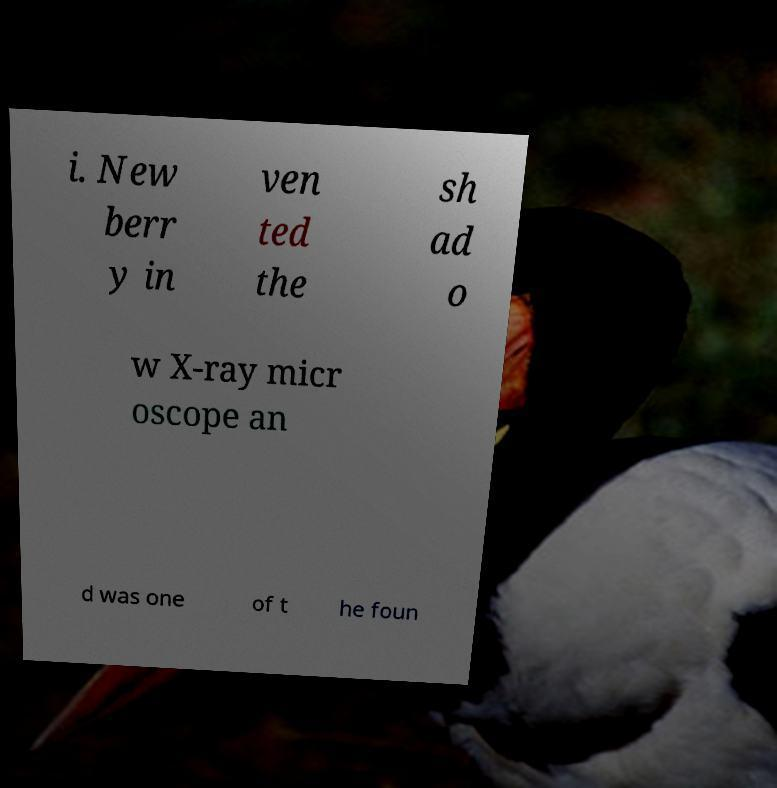I need the written content from this picture converted into text. Can you do that? i. New berr y in ven ted the sh ad o w X-ray micr oscope an d was one of t he foun 